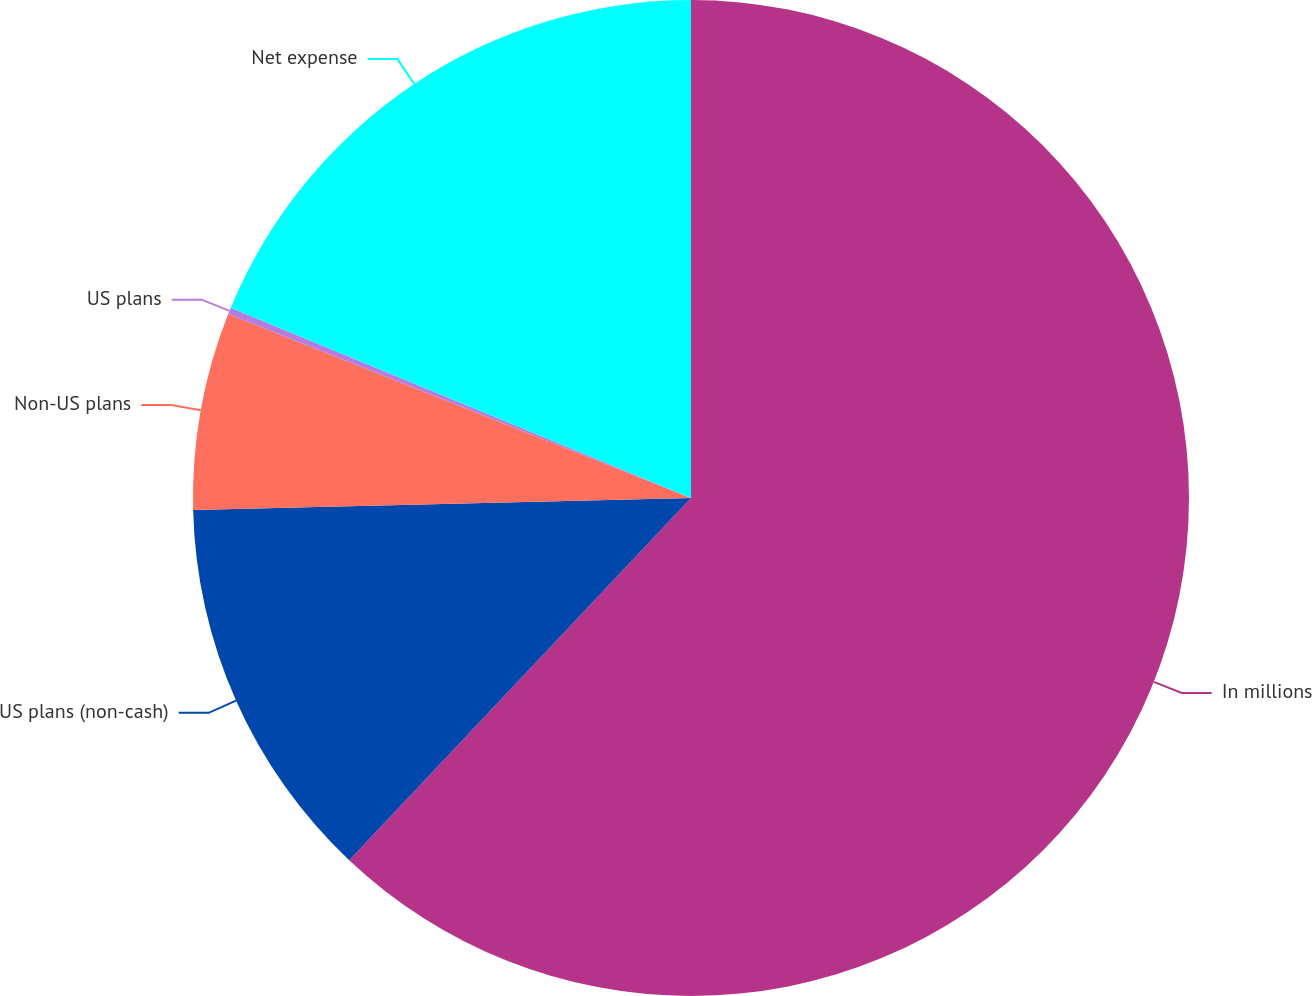Convert chart. <chart><loc_0><loc_0><loc_500><loc_500><pie_chart><fcel>In millions<fcel>US plans (non-cash)<fcel>Non-US plans<fcel>US plans<fcel>Net expense<nl><fcel>62.04%<fcel>12.58%<fcel>6.4%<fcel>0.22%<fcel>18.76%<nl></chart> 